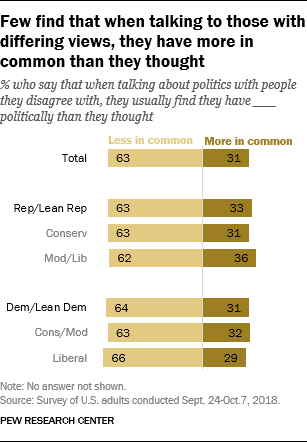Point out several critical features in this image. The value of the rightmost and topmost bar is 31. The ratio of light brown bar occurrences with values 63 and dark brown bar occurrences with values 31 is 0.16875.. 